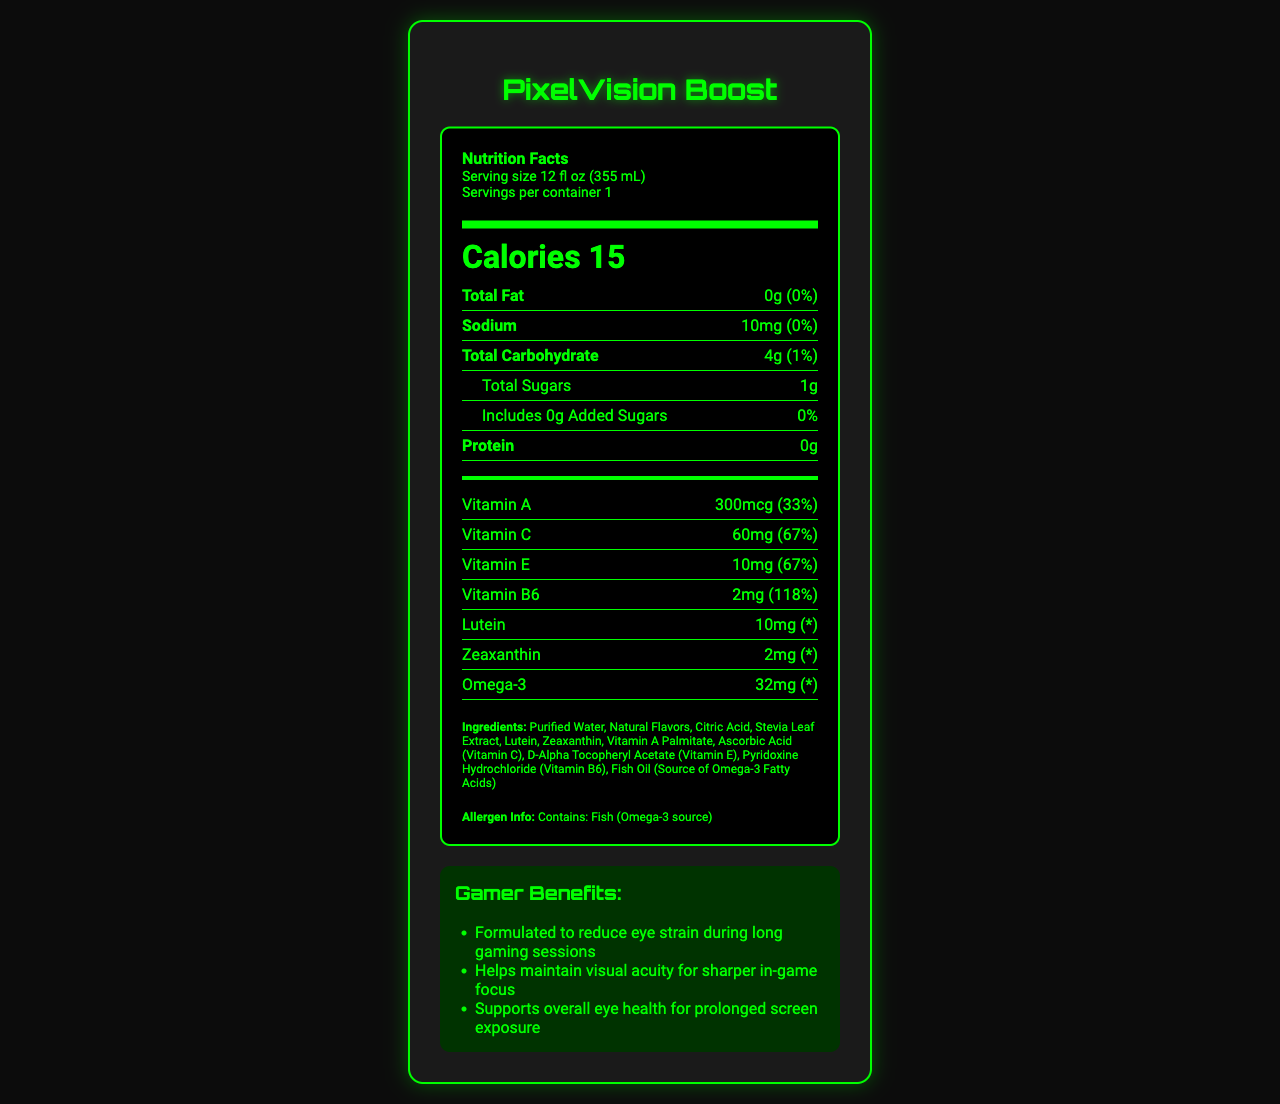what is the serving size of PixelVision Boost? Serving size information is explicitly mentioned as "Serving size 12 fl oz (355 mL)".
Answer: 12 fl oz (355 mL) how many servings per container are there? The document specifies "Servings per container: 1".
Answer: 1 what is the total calorie count in one serving? The document lists "Calories: 15".
Answer: 15 how much Vitamin C is in one serving of PixelVision Boost? The document shows "Vitamin C: 60mg (67%)".
Answer: 60mg what is the main benefit of PixelVision Boost for gamers? One of the listed gamer benefits is "Helps maintain visual acuity for sharper in-game focus".
Answer: Helps maintain visual acuity for sharper in-game focus which ingredient is used for the sweetness of PixelVision Boost? A. Aspartame B. Stevia Leaf Extract C. Sucralose D. High Fructose Corn Syrup The ingredients list includes "Stevia Leaf Extract" and no other sweetening ingredients.
Answer: B. Stevia Leaf Extract which Vitamin has the highest daily value percentage in PixelVision Boost? A. Vitamin A B. Vitamin C C. Vitamin E D. Vitamin B6 The document shows Vitamin B6 has a daily value percentage of 118%, which is the highest among the listed vitamins.
Answer: D. Vitamin B6 is PixelVision Boost free from artificial colors and preservatives? The health claims section mentions "No artificial colors or preservatives".
Answer: Yes does PixelVision Boost contain any allergens? The allergen information states "Contains: Fish (Omega-3 source)".
Answer: Yes, fish summarize the main information found on the PixelVision Boost nutrition label. The document highlights nutritional information, key vitamins and ingredients, and specific benefits for gamers.
Answer: PixelVision Boost is a low-sugar, vitamin-enhanced beverage designed to support eye health during extended screen time. It contains essential vitamins such as A, C, E, and B6, along with antioxidants like lutein and zeaxanthin. Omega-3 is also included, sourced from fish oil. The drink has 15 calories per serving and is free from artificial colors and preservatives. how much energy does PixelVision Boost provide in terms of carbohydrates? The document lists Total Carbohydrate as 4g, contributing to energy.
Answer: 4g what is the main source of Omega-3 in PixelVision Boost? The ingredient list includes "Fish Oil (Source of Omega-3 Fatty Acids)".
Answer: Fish Oil which vitamins in PixelVision Boost support eye health? The vitamins and antioxidants listed, including Lutein and Zeaxanthin, are known for supporting eye health.
Answer: Vitamin A, Vitamin C, Vitamin E, Lutein, Zeaxanthin what percentage of the daily value for sodium does PixelVision Boost provide? The document states that the sodium content is 10mg, which corresponds to 0% of the daily value.
Answer: 0% how much sugar is added to PixelVision Boost? The document specifies "Added Sugars: 0g (0%)".
Answer: 0g how many international units (IU) of Vitamin D are in a serving of PixelVision Boost? The document does not provide any information about Vitamin D content.
Answer: Not enough information 